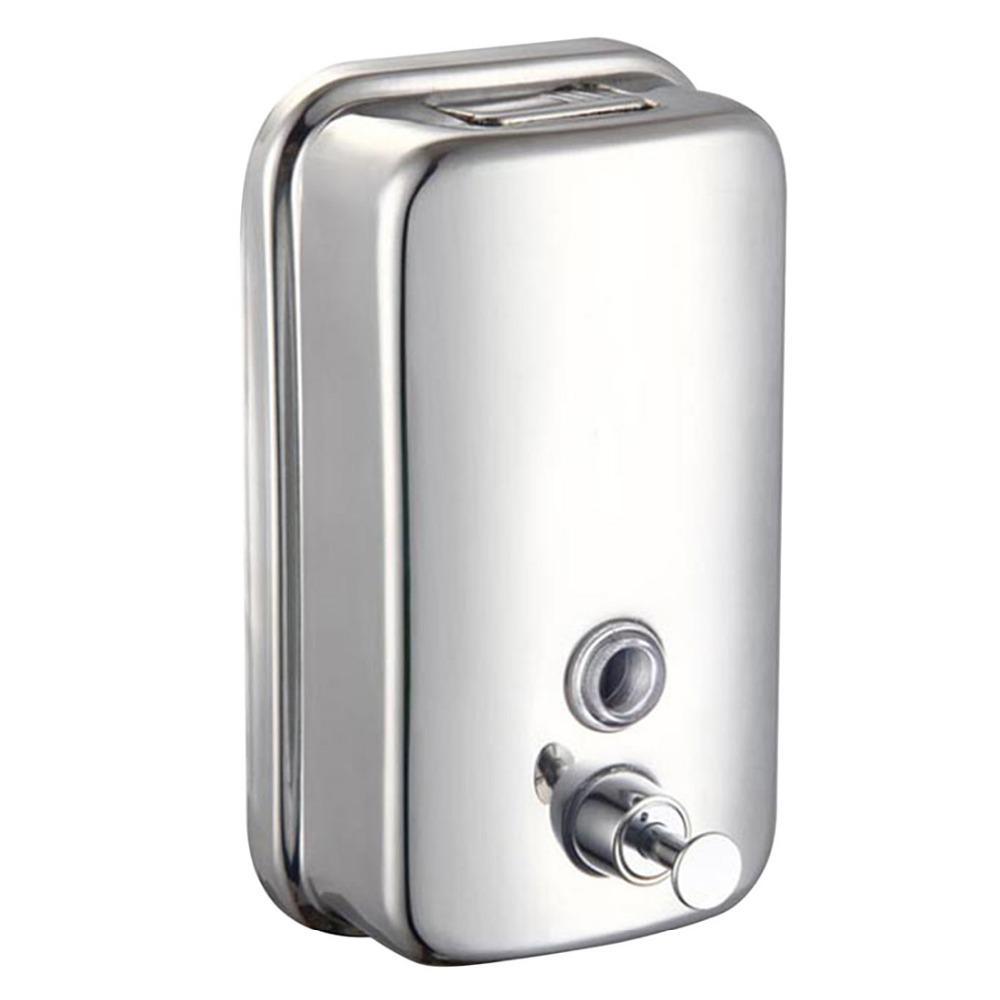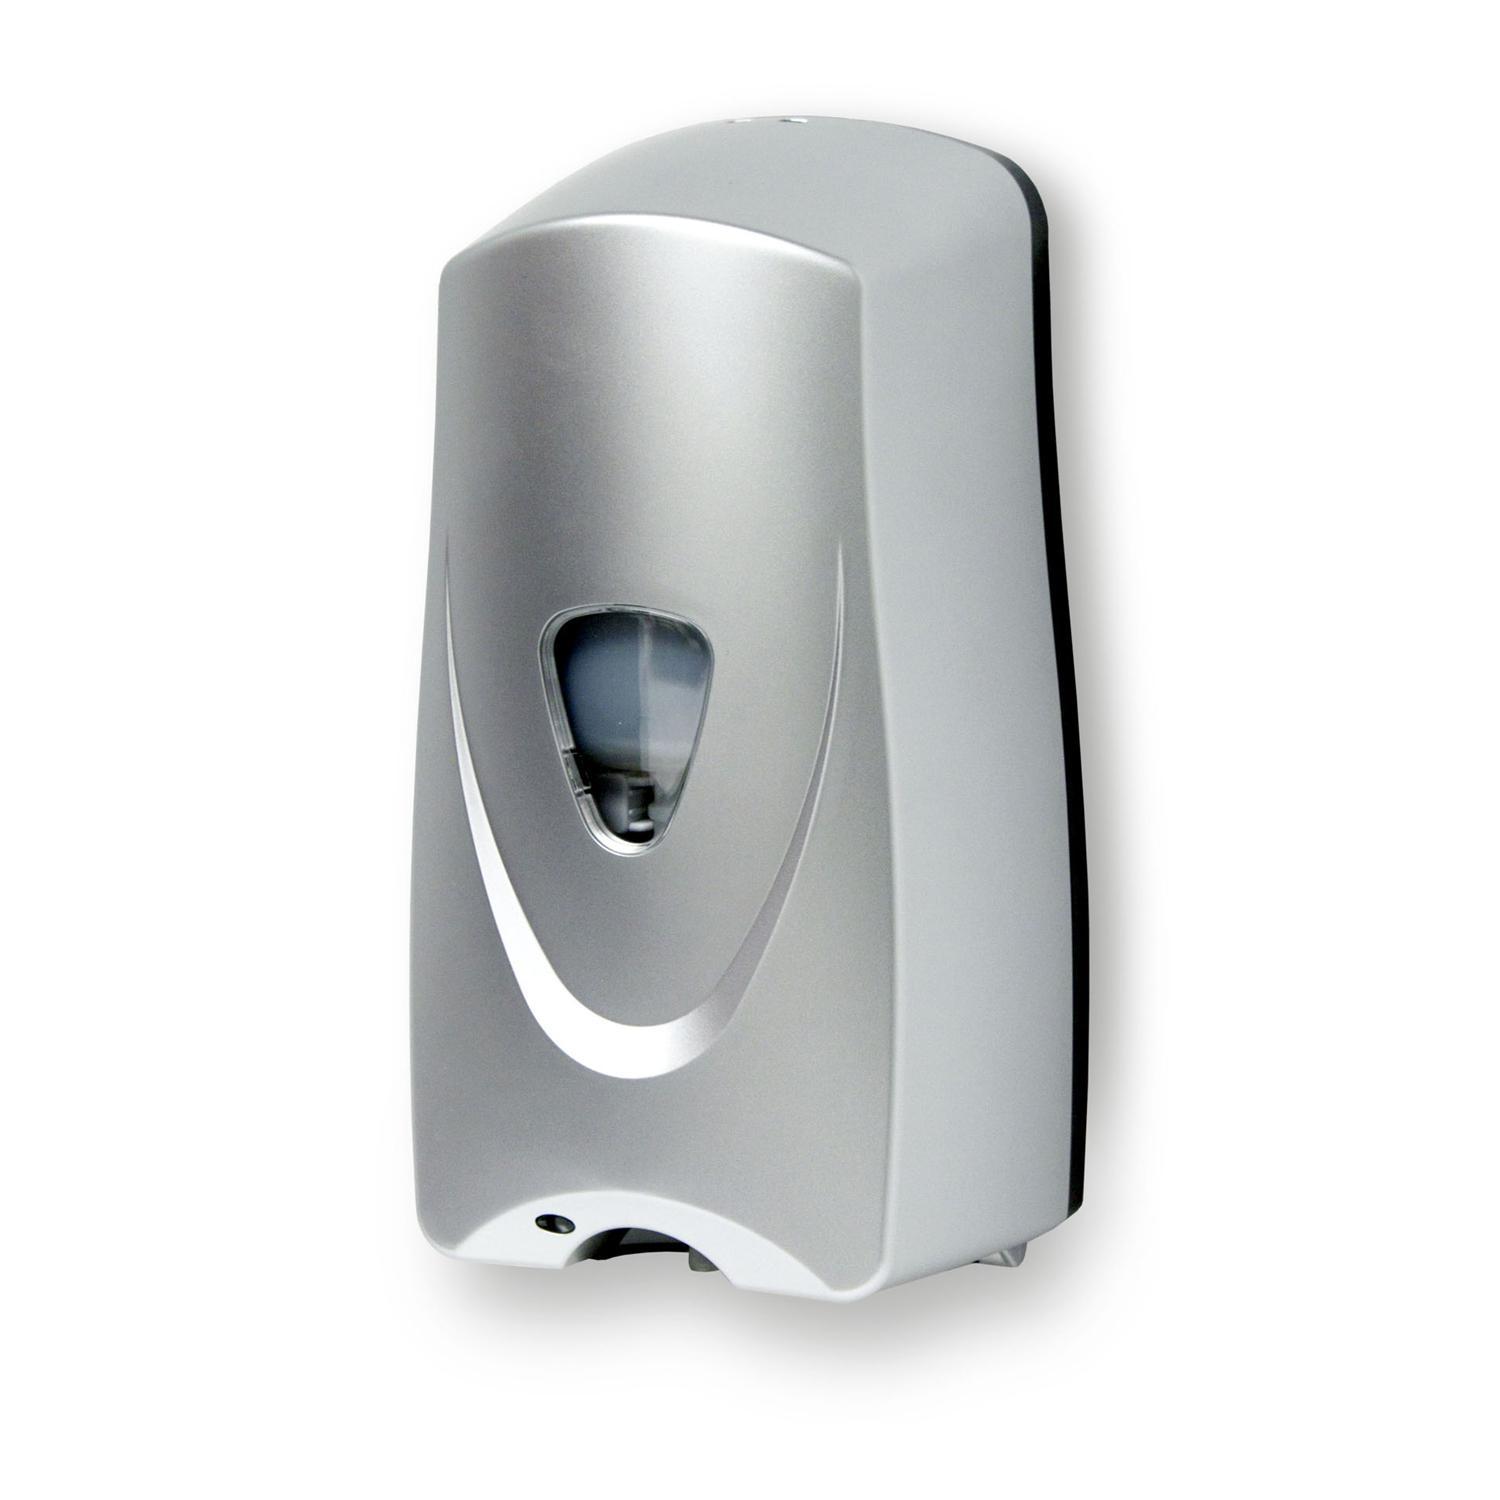The first image is the image on the left, the second image is the image on the right. Analyze the images presented: Is the assertion "The dispenser on the right has a black base." valid? Answer yes or no. No. 